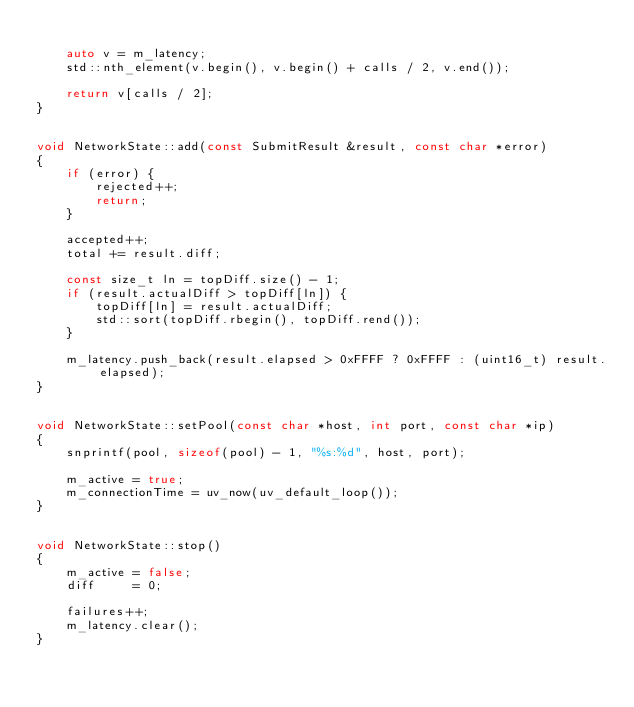<code> <loc_0><loc_0><loc_500><loc_500><_C++_>
    auto v = m_latency;
    std::nth_element(v.begin(), v.begin() + calls / 2, v.end());

    return v[calls / 2];
}


void NetworkState::add(const SubmitResult &result, const char *error)
{
    if (error) {
        rejected++;
        return;
    }

    accepted++;
    total += result.diff;

    const size_t ln = topDiff.size() - 1;
    if (result.actualDiff > topDiff[ln]) {
        topDiff[ln] = result.actualDiff;
        std::sort(topDiff.rbegin(), topDiff.rend());
    }

    m_latency.push_back(result.elapsed > 0xFFFF ? 0xFFFF : (uint16_t) result.elapsed);
}


void NetworkState::setPool(const char *host, int port, const char *ip)
{
    snprintf(pool, sizeof(pool) - 1, "%s:%d", host, port);

    m_active = true;
    m_connectionTime = uv_now(uv_default_loop());
}


void NetworkState::stop()
{
    m_active = false;
    diff     = 0;

    failures++;
    m_latency.clear();
}
</code> 